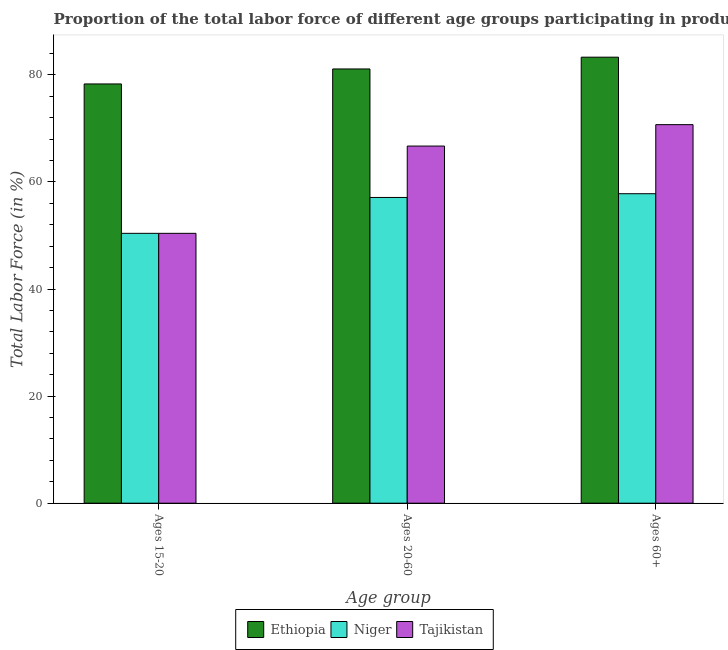How many different coloured bars are there?
Your response must be concise. 3. How many groups of bars are there?
Keep it short and to the point. 3. Are the number of bars per tick equal to the number of legend labels?
Keep it short and to the point. Yes. Are the number of bars on each tick of the X-axis equal?
Ensure brevity in your answer.  Yes. How many bars are there on the 2nd tick from the left?
Offer a terse response. 3. What is the label of the 2nd group of bars from the left?
Offer a very short reply. Ages 20-60. What is the percentage of labor force within the age group 20-60 in Tajikistan?
Give a very brief answer. 66.7. Across all countries, what is the maximum percentage of labor force within the age group 15-20?
Keep it short and to the point. 78.3. Across all countries, what is the minimum percentage of labor force within the age group 20-60?
Your answer should be very brief. 57.1. In which country was the percentage of labor force within the age group 20-60 maximum?
Give a very brief answer. Ethiopia. In which country was the percentage of labor force above age 60 minimum?
Give a very brief answer. Niger. What is the total percentage of labor force within the age group 15-20 in the graph?
Your response must be concise. 179.1. What is the difference between the percentage of labor force within the age group 15-20 in Niger and that in Ethiopia?
Your answer should be very brief. -27.9. What is the difference between the percentage of labor force within the age group 15-20 in Tajikistan and the percentage of labor force above age 60 in Ethiopia?
Your answer should be very brief. -32.9. What is the average percentage of labor force within the age group 20-60 per country?
Make the answer very short. 68.3. What is the difference between the percentage of labor force within the age group 15-20 and percentage of labor force above age 60 in Niger?
Your answer should be very brief. -7.4. What is the ratio of the percentage of labor force within the age group 20-60 in Tajikistan to that in Niger?
Make the answer very short. 1.17. What is the difference between the highest and the second highest percentage of labor force within the age group 20-60?
Offer a very short reply. 14.4. What is the difference between the highest and the lowest percentage of labor force within the age group 15-20?
Give a very brief answer. 27.9. In how many countries, is the percentage of labor force within the age group 15-20 greater than the average percentage of labor force within the age group 15-20 taken over all countries?
Provide a short and direct response. 1. What does the 1st bar from the left in Ages 20-60 represents?
Keep it short and to the point. Ethiopia. What does the 1st bar from the right in Ages 15-20 represents?
Ensure brevity in your answer.  Tajikistan. Are all the bars in the graph horizontal?
Offer a terse response. No. How many countries are there in the graph?
Provide a short and direct response. 3. What is the difference between two consecutive major ticks on the Y-axis?
Your response must be concise. 20. Does the graph contain grids?
Keep it short and to the point. No. How are the legend labels stacked?
Provide a succinct answer. Horizontal. What is the title of the graph?
Offer a very short reply. Proportion of the total labor force of different age groups participating in production in 1991. Does "Channel Islands" appear as one of the legend labels in the graph?
Your response must be concise. No. What is the label or title of the X-axis?
Provide a short and direct response. Age group. What is the label or title of the Y-axis?
Provide a succinct answer. Total Labor Force (in %). What is the Total Labor Force (in %) of Ethiopia in Ages 15-20?
Your response must be concise. 78.3. What is the Total Labor Force (in %) in Niger in Ages 15-20?
Provide a succinct answer. 50.4. What is the Total Labor Force (in %) in Tajikistan in Ages 15-20?
Keep it short and to the point. 50.4. What is the Total Labor Force (in %) in Ethiopia in Ages 20-60?
Your answer should be compact. 81.1. What is the Total Labor Force (in %) in Niger in Ages 20-60?
Your response must be concise. 57.1. What is the Total Labor Force (in %) in Tajikistan in Ages 20-60?
Offer a very short reply. 66.7. What is the Total Labor Force (in %) in Ethiopia in Ages 60+?
Give a very brief answer. 83.3. What is the Total Labor Force (in %) in Niger in Ages 60+?
Ensure brevity in your answer.  57.8. What is the Total Labor Force (in %) of Tajikistan in Ages 60+?
Offer a very short reply. 70.7. Across all Age group, what is the maximum Total Labor Force (in %) of Ethiopia?
Your answer should be compact. 83.3. Across all Age group, what is the maximum Total Labor Force (in %) of Niger?
Give a very brief answer. 57.8. Across all Age group, what is the maximum Total Labor Force (in %) in Tajikistan?
Ensure brevity in your answer.  70.7. Across all Age group, what is the minimum Total Labor Force (in %) in Ethiopia?
Ensure brevity in your answer.  78.3. Across all Age group, what is the minimum Total Labor Force (in %) in Niger?
Keep it short and to the point. 50.4. Across all Age group, what is the minimum Total Labor Force (in %) of Tajikistan?
Your answer should be compact. 50.4. What is the total Total Labor Force (in %) in Ethiopia in the graph?
Your response must be concise. 242.7. What is the total Total Labor Force (in %) in Niger in the graph?
Keep it short and to the point. 165.3. What is the total Total Labor Force (in %) of Tajikistan in the graph?
Offer a very short reply. 187.8. What is the difference between the Total Labor Force (in %) of Niger in Ages 15-20 and that in Ages 20-60?
Offer a very short reply. -6.7. What is the difference between the Total Labor Force (in %) in Tajikistan in Ages 15-20 and that in Ages 20-60?
Offer a very short reply. -16.3. What is the difference between the Total Labor Force (in %) in Ethiopia in Ages 15-20 and that in Ages 60+?
Provide a short and direct response. -5. What is the difference between the Total Labor Force (in %) of Niger in Ages 15-20 and that in Ages 60+?
Your answer should be compact. -7.4. What is the difference between the Total Labor Force (in %) of Tajikistan in Ages 15-20 and that in Ages 60+?
Provide a succinct answer. -20.3. What is the difference between the Total Labor Force (in %) of Ethiopia in Ages 20-60 and that in Ages 60+?
Offer a terse response. -2.2. What is the difference between the Total Labor Force (in %) in Tajikistan in Ages 20-60 and that in Ages 60+?
Your response must be concise. -4. What is the difference between the Total Labor Force (in %) of Ethiopia in Ages 15-20 and the Total Labor Force (in %) of Niger in Ages 20-60?
Offer a very short reply. 21.2. What is the difference between the Total Labor Force (in %) of Ethiopia in Ages 15-20 and the Total Labor Force (in %) of Tajikistan in Ages 20-60?
Your answer should be compact. 11.6. What is the difference between the Total Labor Force (in %) in Niger in Ages 15-20 and the Total Labor Force (in %) in Tajikistan in Ages 20-60?
Make the answer very short. -16.3. What is the difference between the Total Labor Force (in %) of Ethiopia in Ages 15-20 and the Total Labor Force (in %) of Niger in Ages 60+?
Keep it short and to the point. 20.5. What is the difference between the Total Labor Force (in %) in Niger in Ages 15-20 and the Total Labor Force (in %) in Tajikistan in Ages 60+?
Your answer should be very brief. -20.3. What is the difference between the Total Labor Force (in %) in Ethiopia in Ages 20-60 and the Total Labor Force (in %) in Niger in Ages 60+?
Ensure brevity in your answer.  23.3. What is the difference between the Total Labor Force (in %) in Ethiopia in Ages 20-60 and the Total Labor Force (in %) in Tajikistan in Ages 60+?
Make the answer very short. 10.4. What is the difference between the Total Labor Force (in %) of Niger in Ages 20-60 and the Total Labor Force (in %) of Tajikistan in Ages 60+?
Make the answer very short. -13.6. What is the average Total Labor Force (in %) of Ethiopia per Age group?
Offer a terse response. 80.9. What is the average Total Labor Force (in %) of Niger per Age group?
Make the answer very short. 55.1. What is the average Total Labor Force (in %) of Tajikistan per Age group?
Offer a very short reply. 62.6. What is the difference between the Total Labor Force (in %) in Ethiopia and Total Labor Force (in %) in Niger in Ages 15-20?
Provide a succinct answer. 27.9. What is the difference between the Total Labor Force (in %) of Ethiopia and Total Labor Force (in %) of Tajikistan in Ages 15-20?
Your answer should be compact. 27.9. What is the difference between the Total Labor Force (in %) of Niger and Total Labor Force (in %) of Tajikistan in Ages 15-20?
Offer a terse response. 0. What is the ratio of the Total Labor Force (in %) of Ethiopia in Ages 15-20 to that in Ages 20-60?
Your response must be concise. 0.97. What is the ratio of the Total Labor Force (in %) in Niger in Ages 15-20 to that in Ages 20-60?
Your answer should be compact. 0.88. What is the ratio of the Total Labor Force (in %) of Tajikistan in Ages 15-20 to that in Ages 20-60?
Your answer should be very brief. 0.76. What is the ratio of the Total Labor Force (in %) in Ethiopia in Ages 15-20 to that in Ages 60+?
Ensure brevity in your answer.  0.94. What is the ratio of the Total Labor Force (in %) of Niger in Ages 15-20 to that in Ages 60+?
Your answer should be compact. 0.87. What is the ratio of the Total Labor Force (in %) of Tajikistan in Ages 15-20 to that in Ages 60+?
Your response must be concise. 0.71. What is the ratio of the Total Labor Force (in %) of Ethiopia in Ages 20-60 to that in Ages 60+?
Your answer should be very brief. 0.97. What is the ratio of the Total Labor Force (in %) of Niger in Ages 20-60 to that in Ages 60+?
Keep it short and to the point. 0.99. What is the ratio of the Total Labor Force (in %) in Tajikistan in Ages 20-60 to that in Ages 60+?
Your answer should be compact. 0.94. What is the difference between the highest and the second highest Total Labor Force (in %) in Ethiopia?
Keep it short and to the point. 2.2. What is the difference between the highest and the lowest Total Labor Force (in %) of Niger?
Give a very brief answer. 7.4. What is the difference between the highest and the lowest Total Labor Force (in %) of Tajikistan?
Make the answer very short. 20.3. 